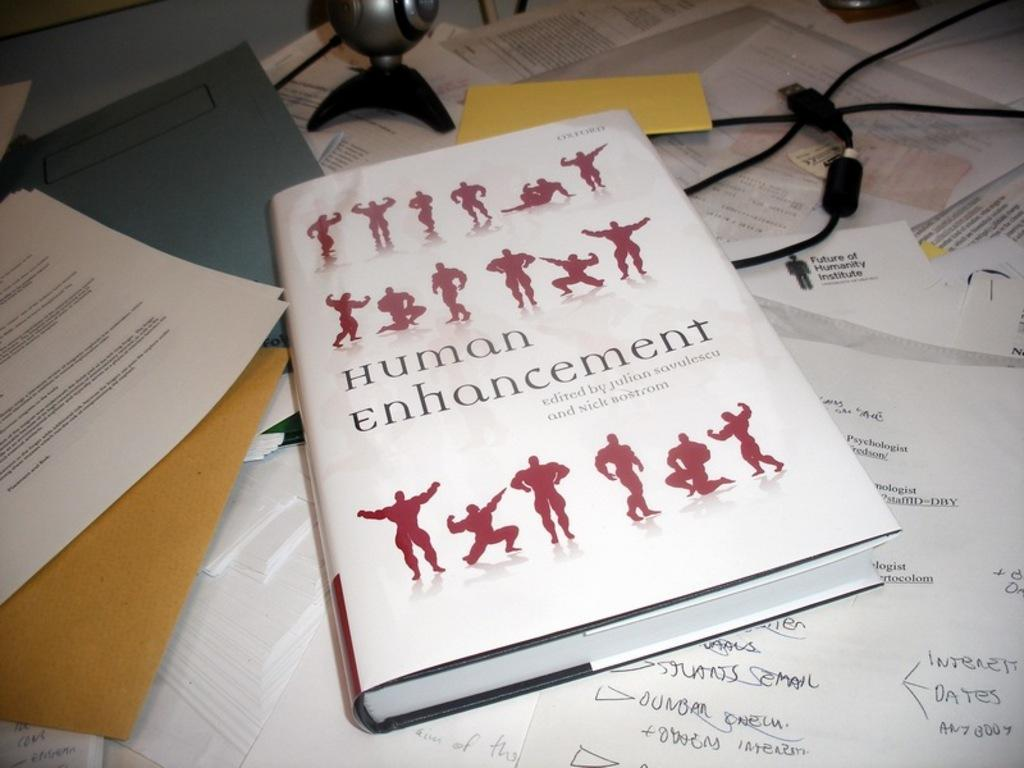What type of items with text can be seen in the image? There are papers with text in the image. What type of reading material is present in the image? There is a book in the image. What type of storage items are visible in the image? There are files in the image. What type of electronic components are present in the image? There are cables in the image. What other objects can be seen on the table in the image? There are other objects on the table in the image. What type of railway is visible in the image? There is no railway present in the image. What type of loaf is being sliced on the table in the image? There is no loaf present in the image. 